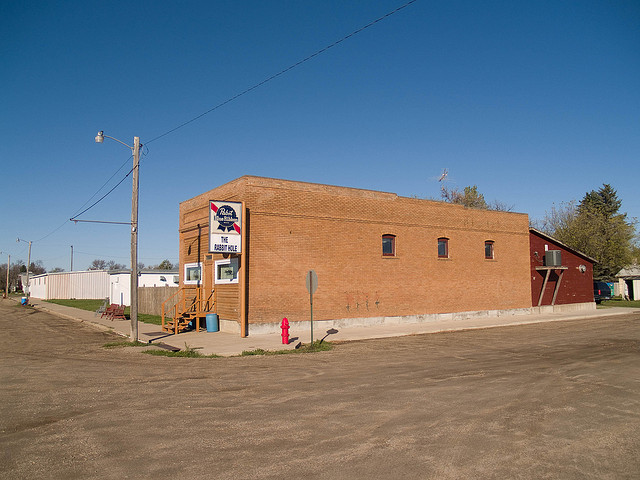<image>What is the date? The date is unknown as there are different dates presented like 'June', '1999', '1990', '2016', 'today', '01012015', '1 6 17', 'noon'. Why is the hydraulic pump on the street? It is unclear why the hydraulic pump is on the street as there is no pump present in the image. What sign is on the street ground? I am unsure. The sign on the street ground can either be a 'stop sign', a 'market store sign', or a 'beer brand sign'. What is the date? I don't know what the date is. It can be any of the options mentioned. Why is the hydraulic pump on the street? I don't know why the hydraulic pump is on the street. It can be for fire or water related reasons. What sign is on the street ground? It is ambiguous what sign is on the street ground. It can be seen 'stop sign', 'market store sign' or 'beer brand sign'. 